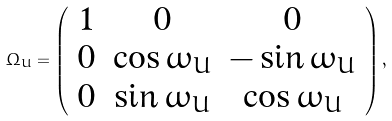Convert formula to latex. <formula><loc_0><loc_0><loc_500><loc_500>\Omega _ { U } = \left ( \begin{array} { c c c } 1 & 0 & 0 \\ 0 & \cos \omega _ { U } & - \sin \omega _ { U } \\ 0 & \sin \omega _ { U } & \cos \omega _ { U } \end{array} \right ) ,</formula> 